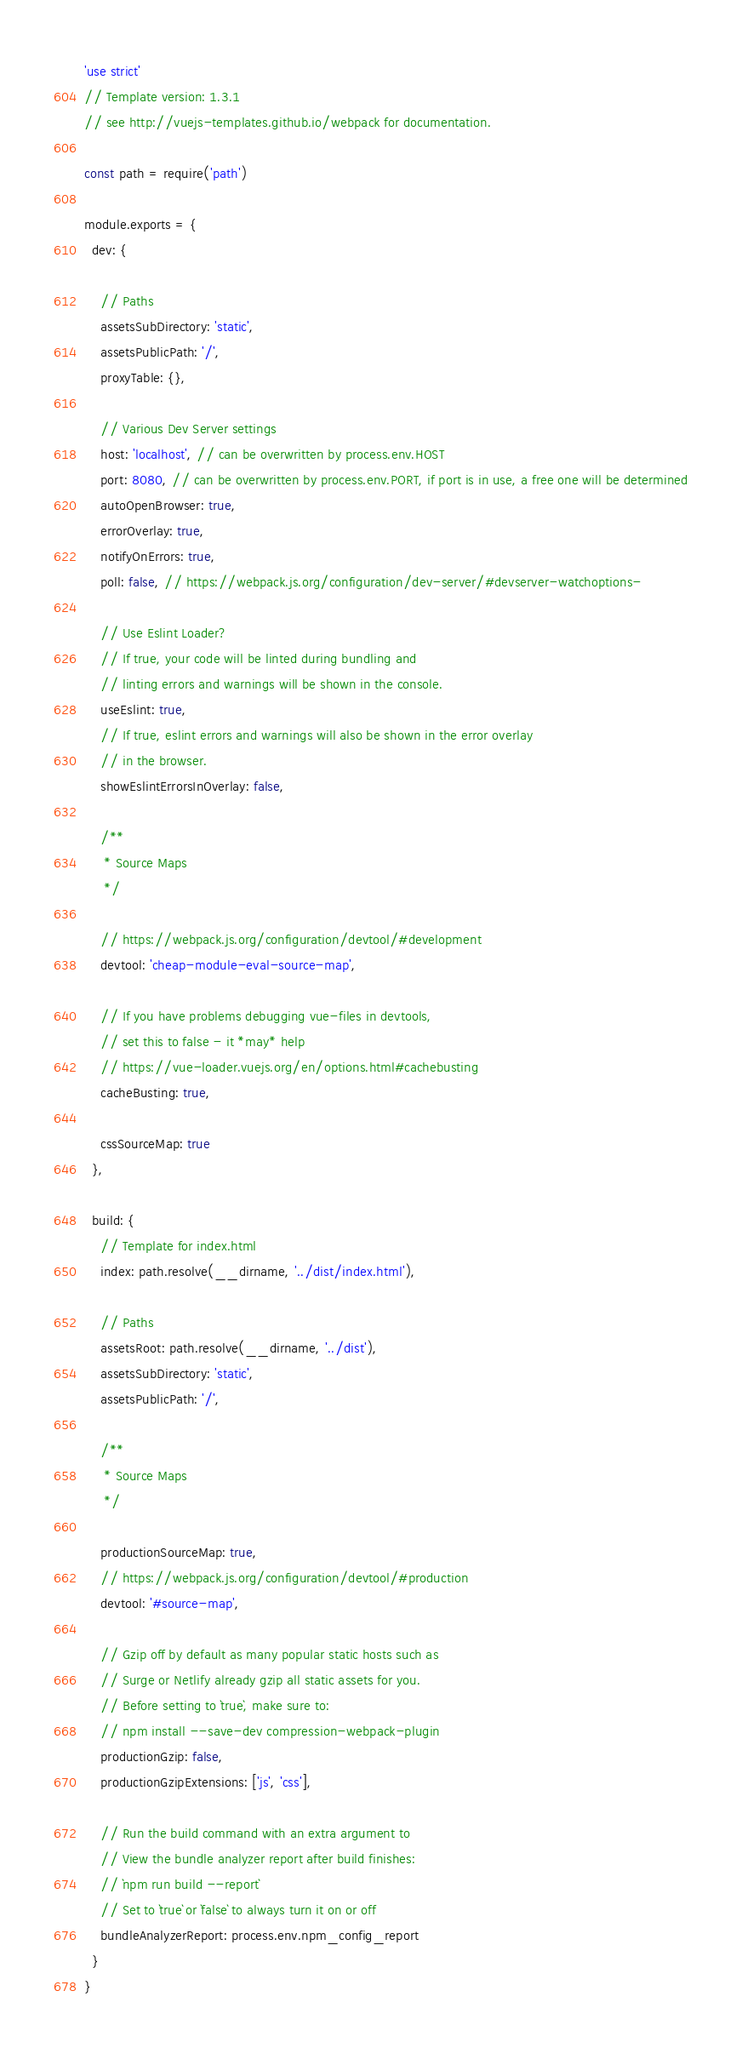Convert code to text. <code><loc_0><loc_0><loc_500><loc_500><_JavaScript_>'use strict'
// Template version: 1.3.1
// see http://vuejs-templates.github.io/webpack for documentation.

const path = require('path')

module.exports = {
  dev: {

    // Paths
    assetsSubDirectory: 'static',
    assetsPublicPath: '/',
    proxyTable: {},

    // Various Dev Server settings
    host: 'localhost', // can be overwritten by process.env.HOST
    port: 8080, // can be overwritten by process.env.PORT, if port is in use, a free one will be determined
    autoOpenBrowser: true,
    errorOverlay: true,
    notifyOnErrors: true,
    poll: false, // https://webpack.js.org/configuration/dev-server/#devserver-watchoptions-

    // Use Eslint Loader?
    // If true, your code will be linted during bundling and
    // linting errors and warnings will be shown in the console.
    useEslint: true,
    // If true, eslint errors and warnings will also be shown in the error overlay
    // in the browser.
    showEslintErrorsInOverlay: false,

    /**
     * Source Maps
     */

    // https://webpack.js.org/configuration/devtool/#development
    devtool: 'cheap-module-eval-source-map',

    // If you have problems debugging vue-files in devtools,
    // set this to false - it *may* help
    // https://vue-loader.vuejs.org/en/options.html#cachebusting
    cacheBusting: true,

    cssSourceMap: true
  },

  build: {
    // Template for index.html
    index: path.resolve(__dirname, '../dist/index.html'),

    // Paths
    assetsRoot: path.resolve(__dirname, '../dist'),
    assetsSubDirectory: 'static',
    assetsPublicPath: '/',

    /**
     * Source Maps
     */

    productionSourceMap: true,
    // https://webpack.js.org/configuration/devtool/#production
    devtool: '#source-map',

    // Gzip off by default as many popular static hosts such as
    // Surge or Netlify already gzip all static assets for you.
    // Before setting to `true`, make sure to:
    // npm install --save-dev compression-webpack-plugin
    productionGzip: false,
    productionGzipExtensions: ['js', 'css'],

    // Run the build command with an extra argument to
    // View the bundle analyzer report after build finishes:
    // `npm run build --report`
    // Set to `true` or `false` to always turn it on or off
    bundleAnalyzerReport: process.env.npm_config_report
  }
}
</code> 